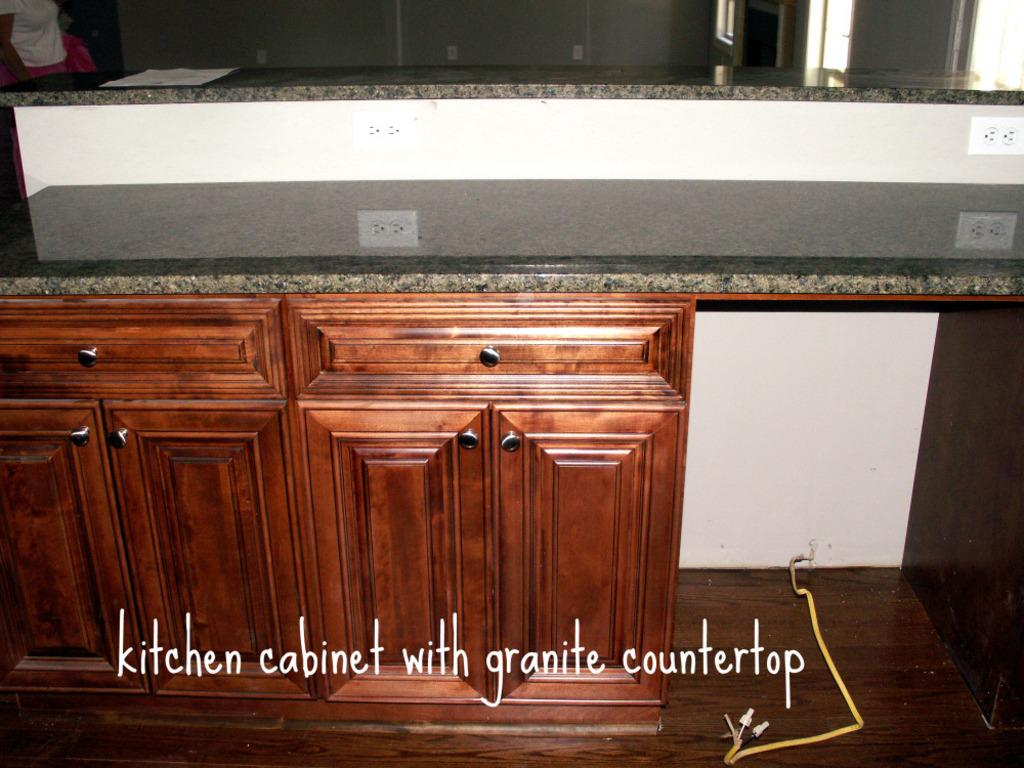What type of furniture is present in the image? There are wooden cupboards in the image. What is located beside the wooden cupboards? There is a white plank beside the cupboards. What is on top of the white plank? There is a plank with switch sockets on top of the white plank. What is the price of the gun in the image? There is no gun present in the image, so it is not possible to determine its price. 